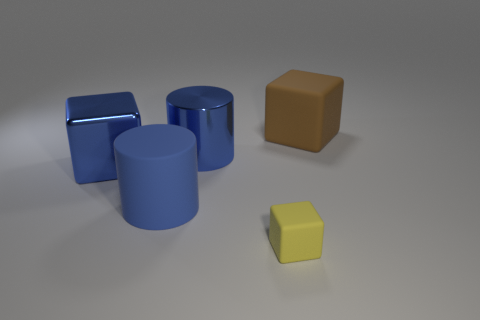Subtract all blue blocks. How many blocks are left? 2 Subtract 2 blocks. How many blocks are left? 1 Add 3 big blue metallic cylinders. How many objects exist? 8 Subtract all brown blocks. How many blocks are left? 2 Subtract 0 cyan cylinders. How many objects are left? 5 Subtract all cylinders. How many objects are left? 3 Subtract all yellow cylinders. Subtract all gray cubes. How many cylinders are left? 2 Subtract all gray spheres. How many brown blocks are left? 1 Subtract all big brown rubber cubes. Subtract all brown matte blocks. How many objects are left? 3 Add 5 big blue rubber things. How many big blue rubber things are left? 6 